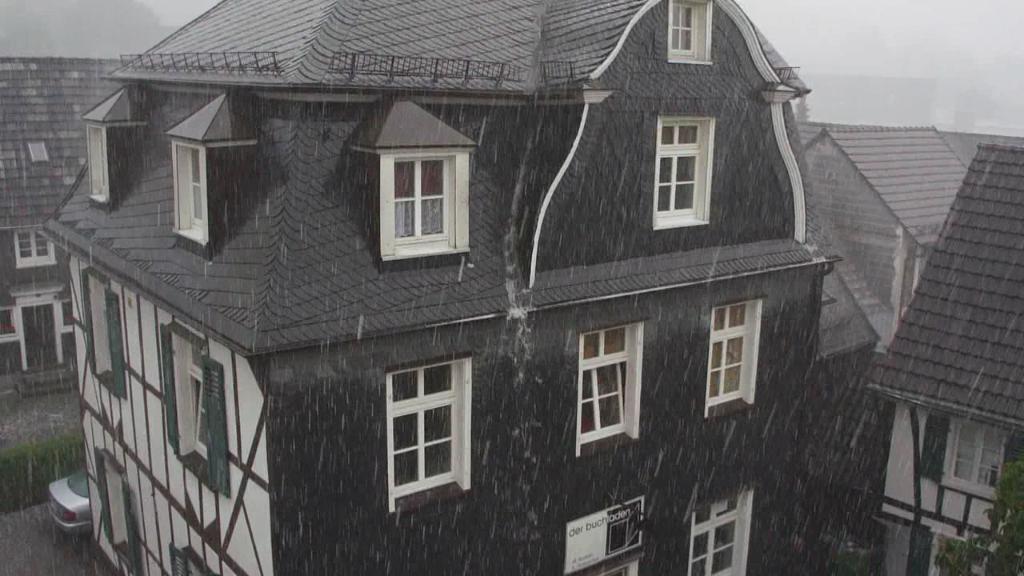Describe this image in one or two sentences. In this image we can see buildings and on road one car is there. 